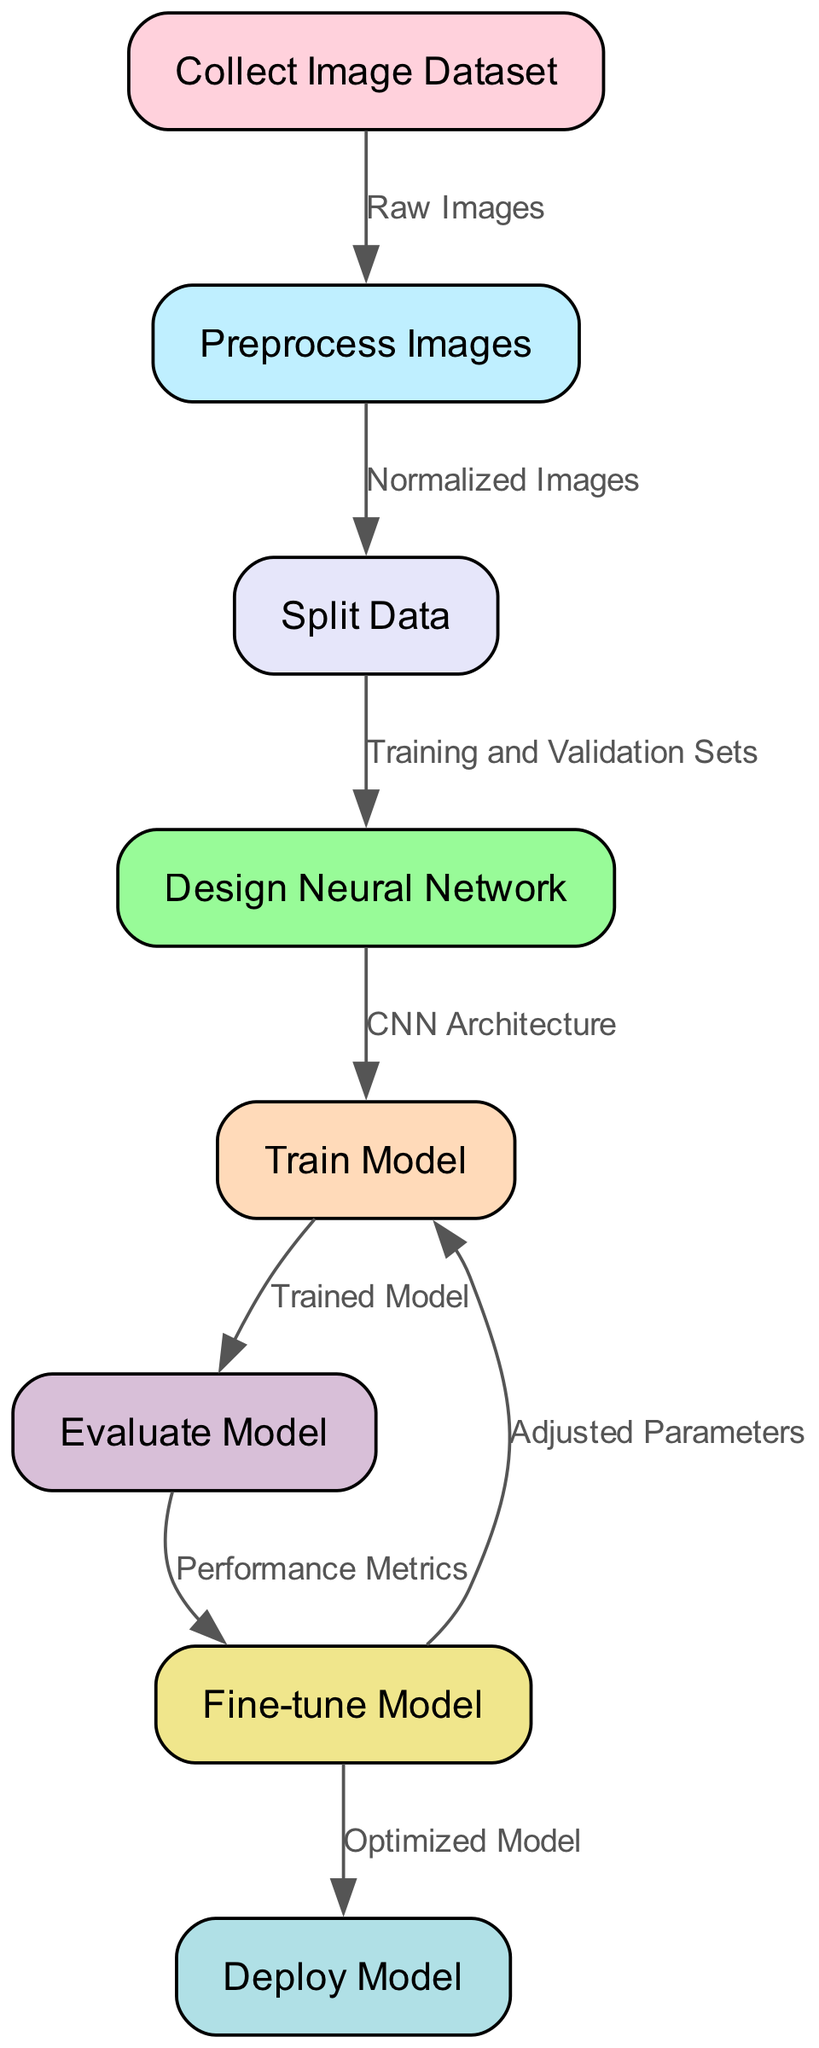What is the first step in the neural network training process? The diagram starts with the node labeled "Collect Image Dataset," indicating that this is the first step in the training process.
Answer: Collect Image Dataset How many nodes are present in the diagram? The diagram includes a total of eight nodes representing various steps in the neural network training process.
Answer: Eight What type of architecture is designed in step four? The diagram specifies "CNN Architecture" as the type of architecture being designed in step four, indicating a Convolutional Neural Network.
Answer: CNN Architecture What do the normalized images lead to in the flowchart? The flowchart shows that normalized images from the preprocessing step lead to the "Split Data" step, indicating that these images are then split into training and validation sets.
Answer: Split Data Which step follows the evaluation of the model? According to the diagram, "Fine-tune Model" directly follows "Evaluate Model," signifying that model adjustments are made based on evaluation results.
Answer: Fine-tune Model What is created after model training? The diagram indicates that after the "Train Model" step, the result is a "Trained Model" which can be evaluated for performance.
Answer: Trained Model Which step involves adjusting parameters? The diagram clearly points out that the "Fine-tune Model" step is where adjustments to parameters are made based on evaluation metrics.
Answer: Adjusted Parameters What leads to the deployment of the model? The "Optimized Model" is the final output from the fine-tuning step before proceeding to deploy the model, demonstrating the flow from fine-tuning to deployment.
Answer: Deploy Model What are the performance metrics associated with? The diagram states that "Performance Metrics" are connected to the evaluation of the model, showing they are derived from the evaluation results.
Answer: Evaluate Model 